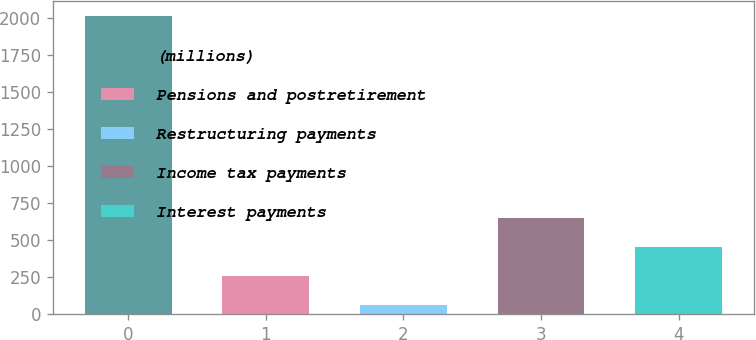Convert chart to OTSL. <chart><loc_0><loc_0><loc_500><loc_500><bar_chart><fcel>(millions)<fcel>Pensions and postretirement<fcel>Restructuring payments<fcel>Income tax payments<fcel>Interest payments<nl><fcel>2015<fcel>257.03<fcel>61.7<fcel>647.69<fcel>452.36<nl></chart> 